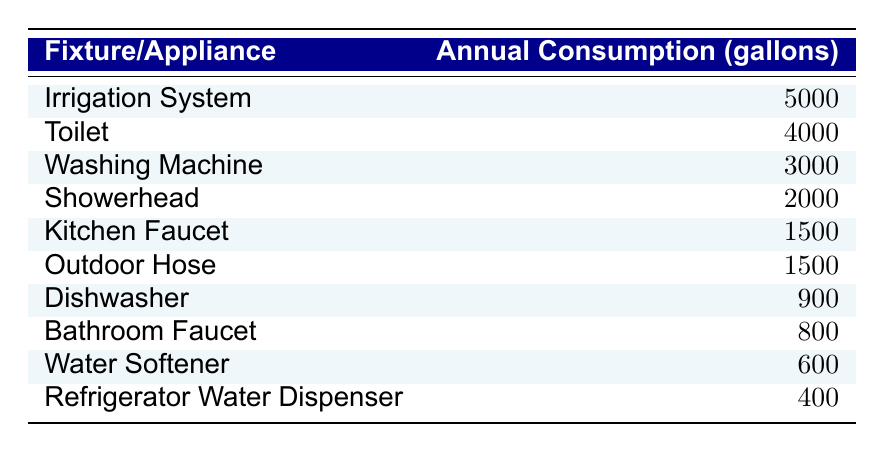What is the annual water consumption of the Toilet? According to the table, the Toilet has an annual consumption of 4000 gallons.
Answer: 4000 gallons Which fixture consumes less water, the Bathroom Faucet or the Dishwasher? The Bathroom Faucet consumes 800 gallons annually, whereas the Dishwasher consumes 900 gallons. Since 800 is less than 900, the Bathroom Faucet consumes less water.
Answer: Bathroom Faucet What is the total annual water consumption of the Irrigation System and the Washing Machine? The Irrigation System consumes 5000 gallons, and the Washing Machine consumes 3000 gallons. Adding these gives a total of 5000 + 3000 = 8000 gallons.
Answer: 8000 gallons Is the annual water consumption of the Kitchen Faucet greater than 1500 gallons? The Kitchen Faucet has an annual consumption of 1500 gallons, which is not greater than 1500. Therefore, the statement is false.
Answer: No What is the median annual water consumption among all listed fixtures? First, we need to list all the annual consumptions: 5000, 4000, 3000, 2000, 1500, 1500, 900, 800, 600, 400. Sorting these, we get: 400, 600, 800, 900, 1500, 1500, 2000, 3000, 4000, 5000. With ten numbers, the median is the average of the 5th and 6th values (1500 and 1500), so (1500 + 1500)/2 = 1500.
Answer: 1500 gallons Which appliance has the highest annual water consumption? The table shows that the Irrigation System consumes 5000 gallons, which is higher than all other fixtures.
Answer: Irrigation System How much more water does the Toilet consume than the Refrigerator Water Dispenser? The Toilet’s consumption is 4000 gallons and the Refrigerator Water Dispenser’s is 400 gallons. Calculating the difference: 4000 - 400 = 3600 gallons.
Answer: 3600 gallons What percentage of the total annual consumption (for all fixtures) is attributed to the Showerhead? The total annual consumption is 800 + 2000 + 4000 + 3000 + 900 + 1500 + 5000 + 1500 + 600 + 400 = 20000 gallons. The Showerhead consumes 2000 gallons. To find the percentage, (2000 / 20000) * 100 = 10%.
Answer: 10% If we consider the two lowest consuming fixtures, what is their combined consumption? The two lowest consuming fixtures are the Refrigerator Water Dispenser (400 gallons) and the Water Softener (600 gallons). Their combined consumption is 400 + 600 = 1000 gallons.
Answer: 1000 gallons Is the consumption of the Washing Machine more than twice that of the Water Softener? The Washing Machine consumes 3000 gallons, while the Water Softener consumes 600 gallons. Twice the Water Softener's consumption is 2 * 600 = 1200 gallons, and since 3000 is greater than 1200, this statement is true.
Answer: Yes What is the difference in consumption between the highest and lowest consuming fixtures? The highest consuming fixture is the Irrigation System with 5000 gallons, and the lowest is the Refrigerator Water Dispenser with 400 gallons. The difference is 5000 - 400 = 4600 gallons.
Answer: 4600 gallons 